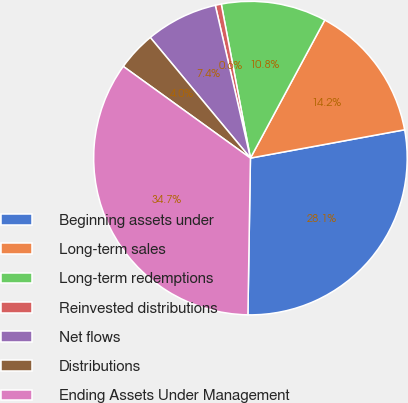Convert chart to OTSL. <chart><loc_0><loc_0><loc_500><loc_500><pie_chart><fcel>Beginning assets under<fcel>Long-term sales<fcel>Long-term redemptions<fcel>Reinvested distributions<fcel>Net flows<fcel>Distributions<fcel>Ending Assets Under Management<nl><fcel>28.15%<fcel>14.25%<fcel>10.84%<fcel>0.62%<fcel>7.43%<fcel>4.03%<fcel>34.69%<nl></chart> 